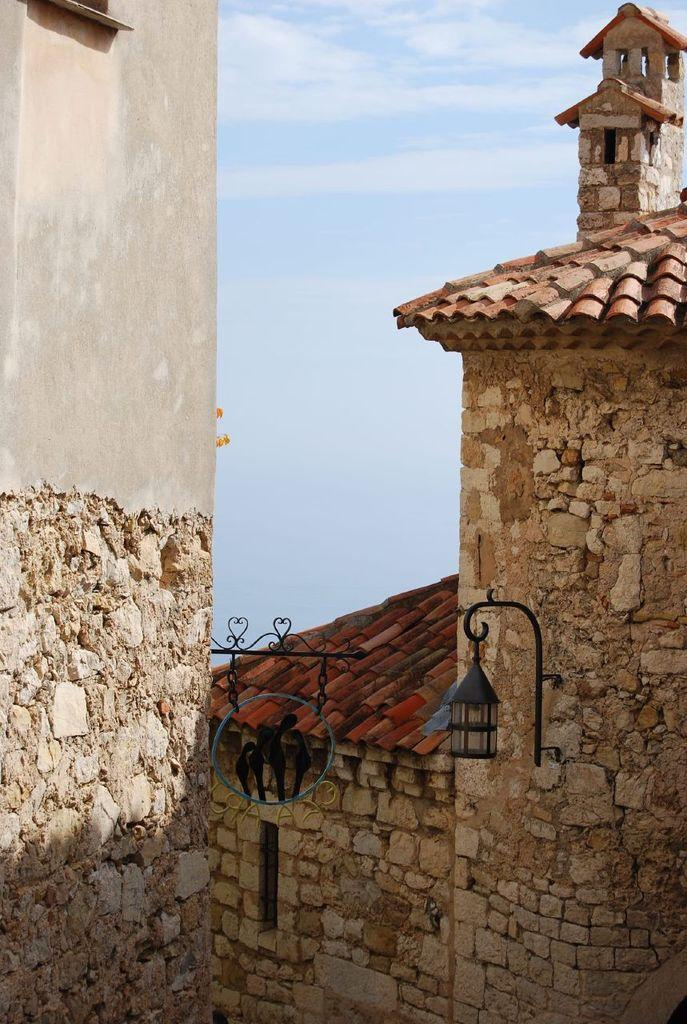What type of structures can be seen in the image? There are buildings in the image. What can be seen illuminating the area in the image? There is a light in the image. What is supporting the light in the image? There is a stand in the image. What is visible in the distance in the image? The sky is visible in the background of the image. Can you see the fang of the creature in the image? There is no creature or fang present in the image. How many eyes can be seen on the watch in the image? There is no watch present in the image. 